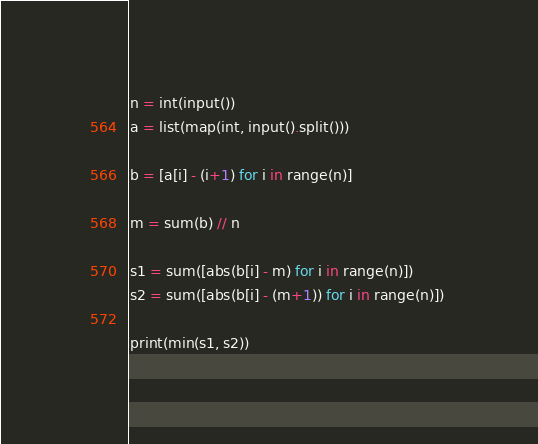Convert code to text. <code><loc_0><loc_0><loc_500><loc_500><_Python_>n = int(input())
a = list(map(int, input().split()))

b = [a[i] - (i+1) for i in range(n)]

m = sum(b) // n

s1 = sum([abs(b[i] - m) for i in range(n)])
s2 = sum([abs(b[i] - (m+1)) for i in range(n)]) 

print(min(s1, s2))</code> 